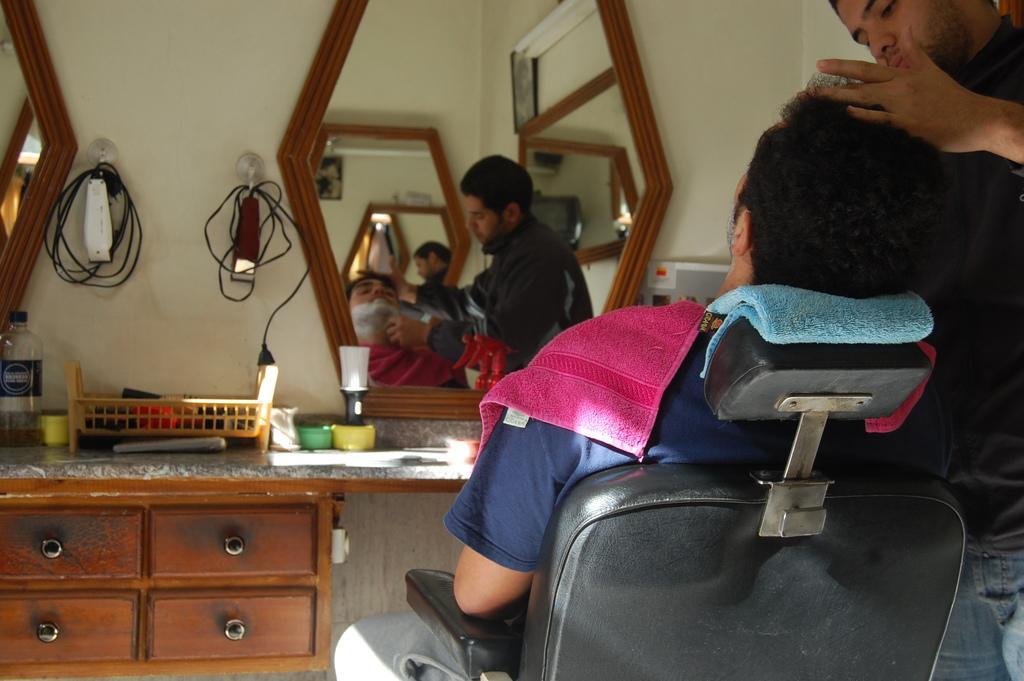Could you give a brief overview of what you see in this image? In this image there is a cupboard, there are objects placed on the surface and hanged on the wall on the left corner. There is a person sitting on the chair and a person standing on the right corner. There is a mirror on the wall in which we can see the reflection of people in the background. 